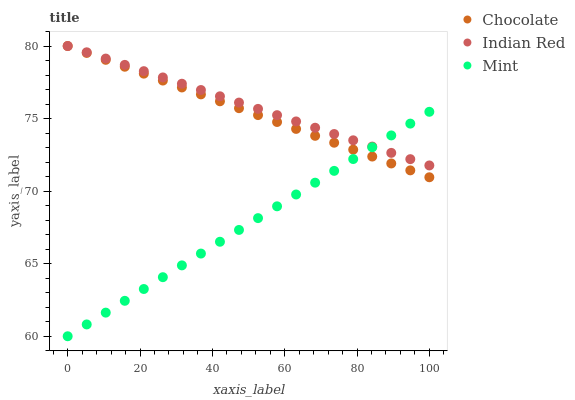Does Mint have the minimum area under the curve?
Answer yes or no. Yes. Does Indian Red have the maximum area under the curve?
Answer yes or no. Yes. Does Chocolate have the minimum area under the curve?
Answer yes or no. No. Does Chocolate have the maximum area under the curve?
Answer yes or no. No. Is Indian Red the smoothest?
Answer yes or no. Yes. Is Chocolate the roughest?
Answer yes or no. Yes. Is Chocolate the smoothest?
Answer yes or no. No. Is Indian Red the roughest?
Answer yes or no. No. Does Mint have the lowest value?
Answer yes or no. Yes. Does Chocolate have the lowest value?
Answer yes or no. No. Does Chocolate have the highest value?
Answer yes or no. Yes. Does Chocolate intersect Indian Red?
Answer yes or no. Yes. Is Chocolate less than Indian Red?
Answer yes or no. No. Is Chocolate greater than Indian Red?
Answer yes or no. No. 